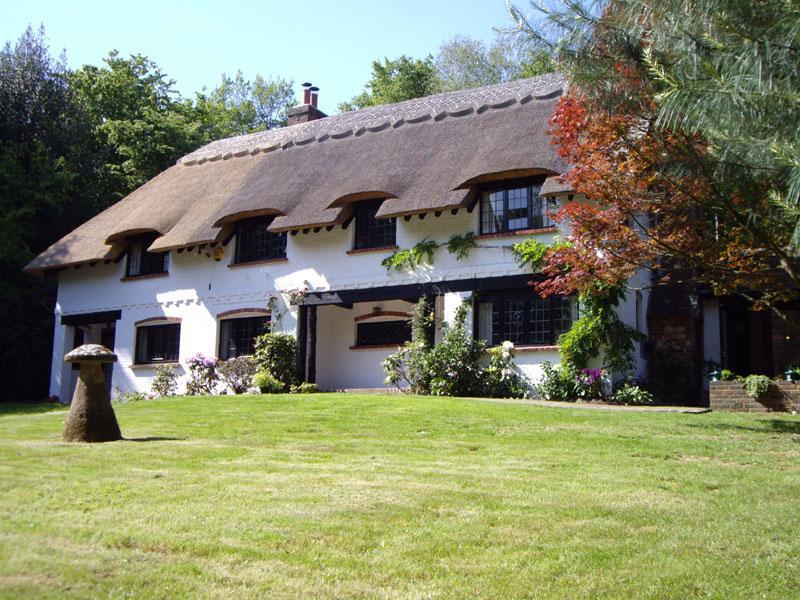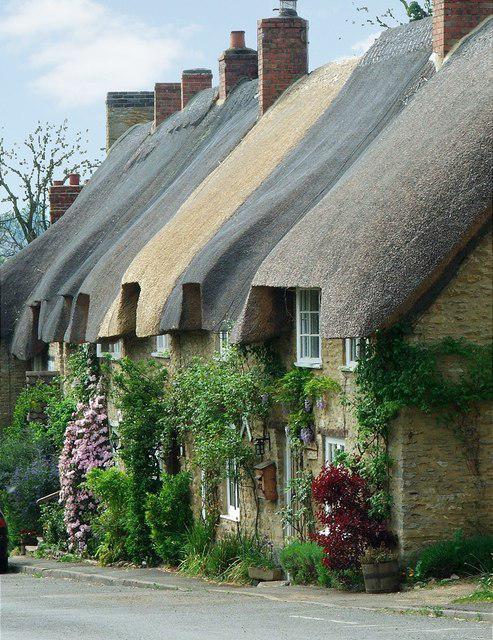The first image is the image on the left, the second image is the image on the right. Considering the images on both sides, is "The left image features a white house with at least two notches in its roof to accomodate windows and a sculpted border along the top of the roof." valid? Answer yes or no. Yes. The first image is the image on the left, the second image is the image on the right. Examine the images to the left and right. Is the description "On the left a green lawn rises up to meet a white country cottage." accurate? Answer yes or no. Yes. 